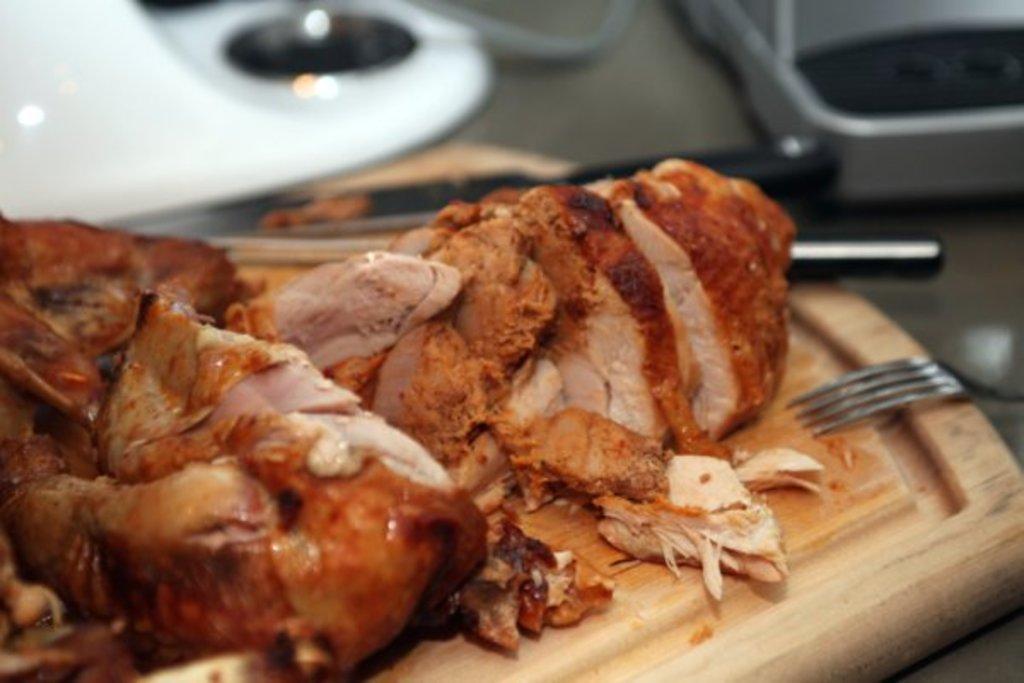Could you give a brief overview of what you see in this image? In this picture we can see a fork, knife, meat on a wooden object and in the background we can see some objects. 